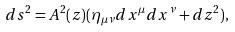Convert formula to latex. <formula><loc_0><loc_0><loc_500><loc_500>d s ^ { 2 } = A ^ { 2 } ( z ) ( \eta _ { \mu \nu } d x ^ { \mu } d x ^ { \nu } + d z ^ { 2 } ) ,</formula> 